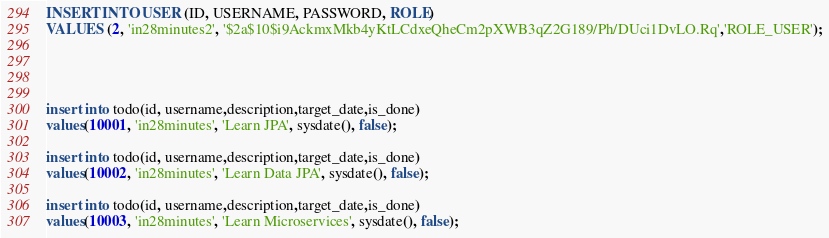Convert code to text. <code><loc_0><loc_0><loc_500><loc_500><_SQL_>INSERT INTO USER (ID, USERNAME, PASSWORD, ROLE) 
VALUES (2, 'in28minutes2', '$2a$10$i9AckmxMkb4yKtLCdxeQheCm2pXWB3qZ2G189/Ph/DUci1DvLO.Rq','ROLE_USER');




insert into todo(id, username,description,target_date,is_done)
values(10001, 'in28minutes', 'Learn JPA', sysdate(), false);

insert into todo(id, username,description,target_date,is_done)
values(10002, 'in28minutes', 'Learn Data JPA', sysdate(), false);

insert into todo(id, username,description,target_date,is_done)
values(10003, 'in28minutes', 'Learn Microservices', sysdate(), false);</code> 